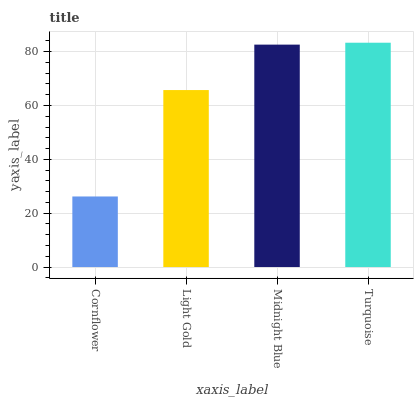Is Cornflower the minimum?
Answer yes or no. Yes. Is Turquoise the maximum?
Answer yes or no. Yes. Is Light Gold the minimum?
Answer yes or no. No. Is Light Gold the maximum?
Answer yes or no. No. Is Light Gold greater than Cornflower?
Answer yes or no. Yes. Is Cornflower less than Light Gold?
Answer yes or no. Yes. Is Cornflower greater than Light Gold?
Answer yes or no. No. Is Light Gold less than Cornflower?
Answer yes or no. No. Is Midnight Blue the high median?
Answer yes or no. Yes. Is Light Gold the low median?
Answer yes or no. Yes. Is Turquoise the high median?
Answer yes or no. No. Is Turquoise the low median?
Answer yes or no. No. 